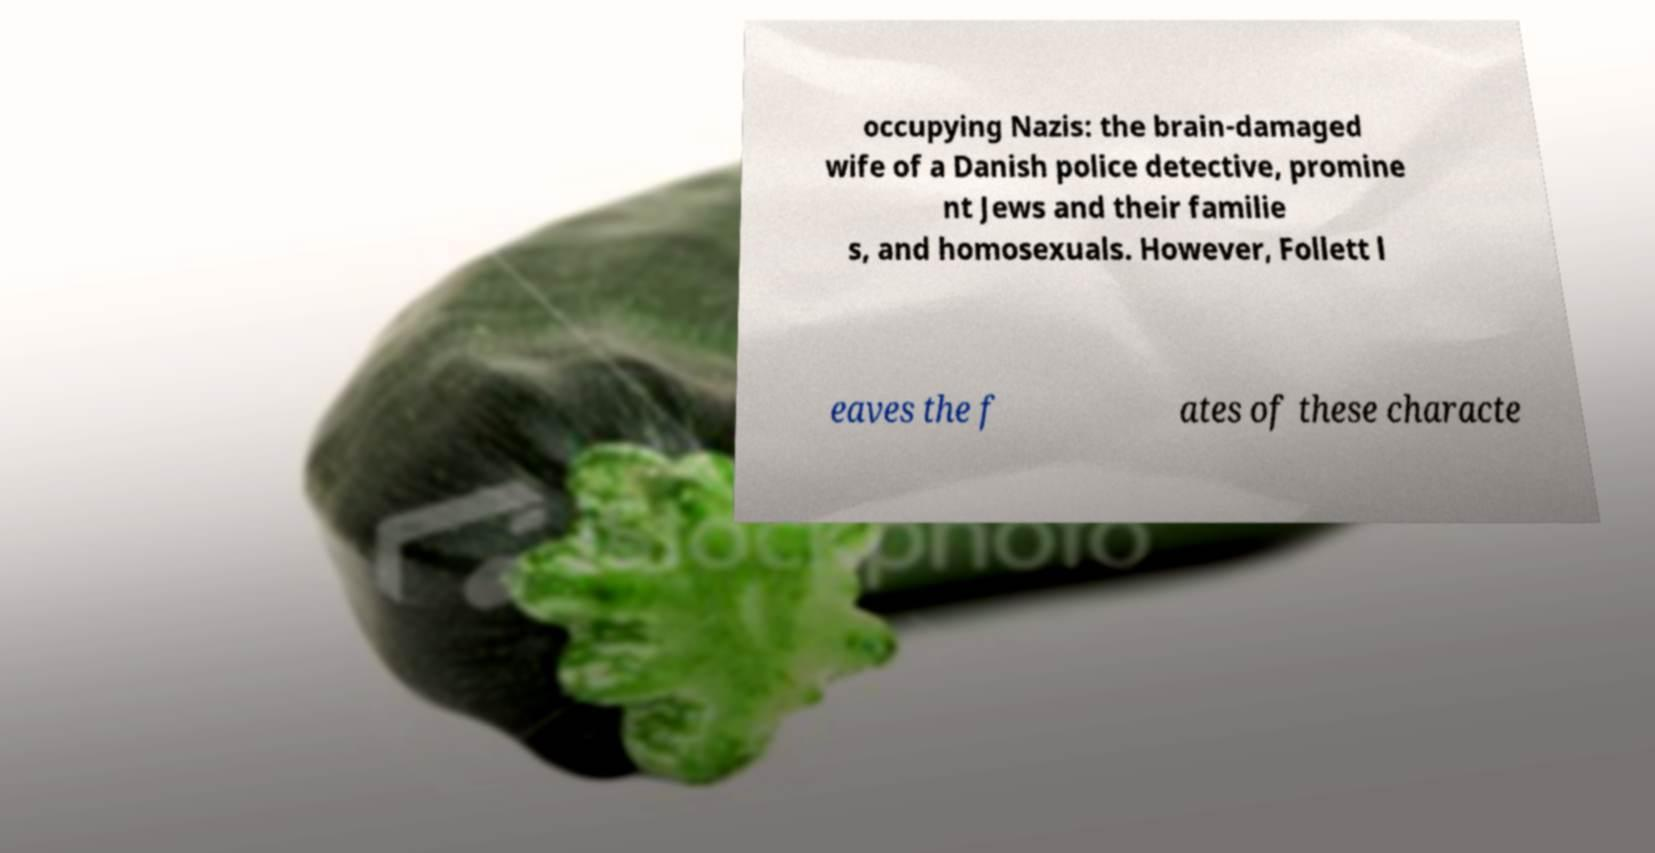For documentation purposes, I need the text within this image transcribed. Could you provide that? occupying Nazis: the brain-damaged wife of a Danish police detective, promine nt Jews and their familie s, and homosexuals. However, Follett l eaves the f ates of these characte 